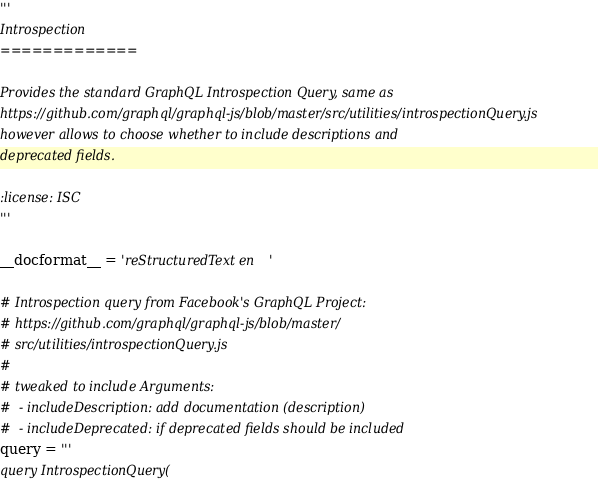Convert code to text. <code><loc_0><loc_0><loc_500><loc_500><_Python_>'''
Introspection
=============

Provides the standard GraphQL Introspection Query, same as
https://github.com/graphql/graphql-js/blob/master/src/utilities/introspectionQuery.js
however allows to choose whether to include descriptions and
deprecated fields.

:license: ISC
'''

__docformat__ = 'reStructuredText en'

# Introspection query from Facebook's GraphQL Project:
# https://github.com/graphql/graphql-js/blob/master/
# src/utilities/introspectionQuery.js
#
# tweaked to include Arguments:
#  - includeDescription: add documentation (description)
#  - includeDeprecated: if deprecated fields should be included
query = '''
query IntrospectionQuery(</code> 